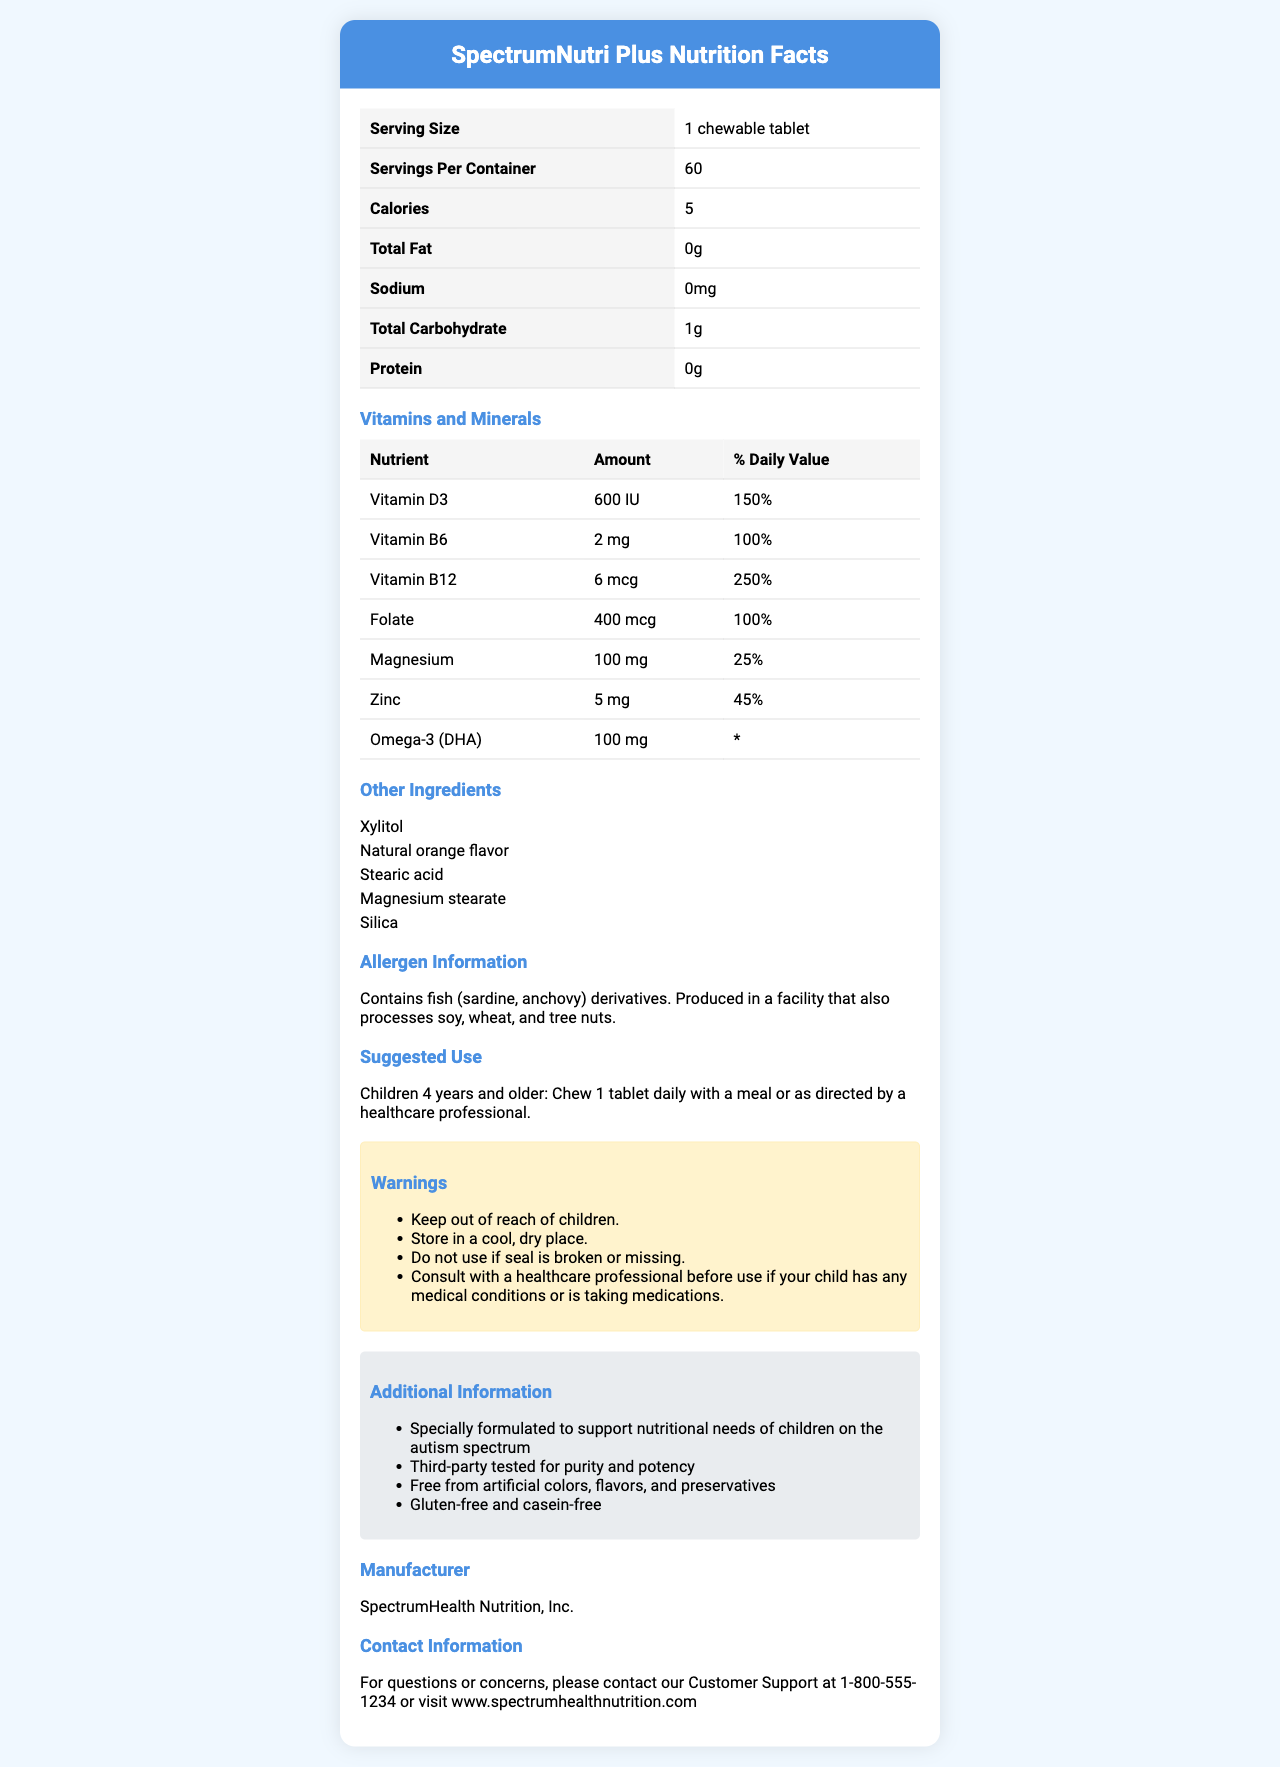what is the product name? The product name is displayed at the top of the document within the header section.
Answer: SpectrumNutri Plus how many chewable tablets are in one container? The document states there are 60 servings per container, and since each serving is one chewable tablet, there are 60 tablets per container.
Answer: 60 how many calories are in one serving? The document lists 5 calories per serving of one chewable tablet.
Answer: 5 what is the daily value percentage of Vitamin B12 per serving? The table under "Vitamins and Minerals" section shows that Vitamin B12 has a daily value of 250%.
Answer: 250% which ingredient is mentioned as a natural flavor in the product? The ingredient list includes "Natural orange flavor" as one of the components.
Answer: Natural orange flavor how should children 4 years and older take this supplement? The suggested use section specifies the dosage and method for children 4 years and older.
Answer: Chew 1 tablet daily with a meal or as directed by a healthcare professional who is the manufacturer of this product? Under the "Manufacturer" section, it states the manufacturer is SpectrumHealth Nutrition, Inc.
Answer: SpectrumHealth Nutrition, Inc. what is the contact phone number for customer support? The contact information section lists the customer support phone number as 1-800-555-1234.
Answer: 1-800-555-1234 what percentage of the daily value of Zinc does one serving provide? The document states under "Vitamins and Minerals" that one serving provides 45% of the daily value for Zinc.
Answer: 45% what should you do if the seal is broken or missing? One of the warnings explicitly states to not use the product if the seal is broken or missing.
Answer: Do not use which of the following vitamins is NOT listed on the document as an ingredient? A. Vitamin D3 B. Vitamin C C. Vitamin B6 D. Folate The document lists Vitamin D3, Vitamin B6, and Folate but does not mention Vitamin C.
Answer: B which allergen is contained in the product? A. Dairy B. Fish C. Peanut D. Egg Under the allergen information section, it states that the product contains fish derivatives.
Answer: B is this product gluten-free and casein-free? The additional information section mentions that the product is gluten-free and casein-free.
Answer: Yes does the document specify that the product is third-party tested? The additional information section states that the product is third-party tested for purity and potency.
Answer: Yes summarize the main purpose of this document. This is a summary of the entire document, capturing all key sections and their purpose.
Answer: The document provides detailed nutritional information about SpectrumNutri Plus, a chewable tablet supplement formulated for children on the autism spectrum. It includes serving size, serving per container, calories, vitamins, and minerals, other ingredients, allergen information, suggested use, warnings, additional information, manufacturer details, and contact information. how many milligrams of Omega-3 (DHA) are in one serving? The "Vitamins and Minerals" section states there are 100 mg of Omega-3 (DHA) per serving.
Answer: 100 mg what is the daily value percentage for magnesium in one serving? According to the vitamins and minerals section, magnesium has a daily value of 25% per serving.
Answer: 25% what flavor is the chewable tablet? The document lists "Natural orange flavor" under the other ingredients section.
Answer: Orange does this supplement contain any soy? While the allergen information mentions the product is produced in a facility that processes soy, it does not explicitly state if the supplement itself contains soy.
Answer: Cannot be determined 